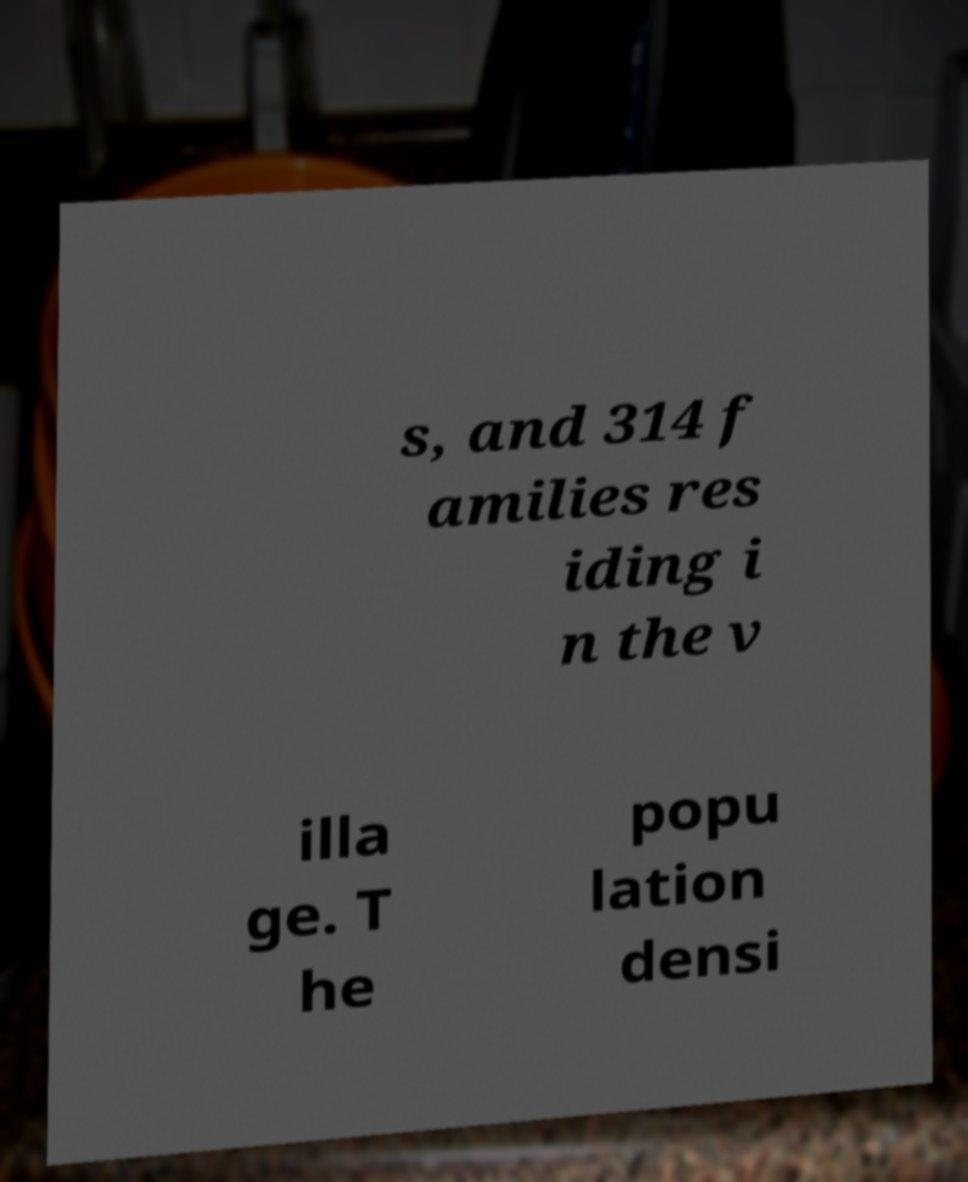Please identify and transcribe the text found in this image. s, and 314 f amilies res iding i n the v illa ge. T he popu lation densi 